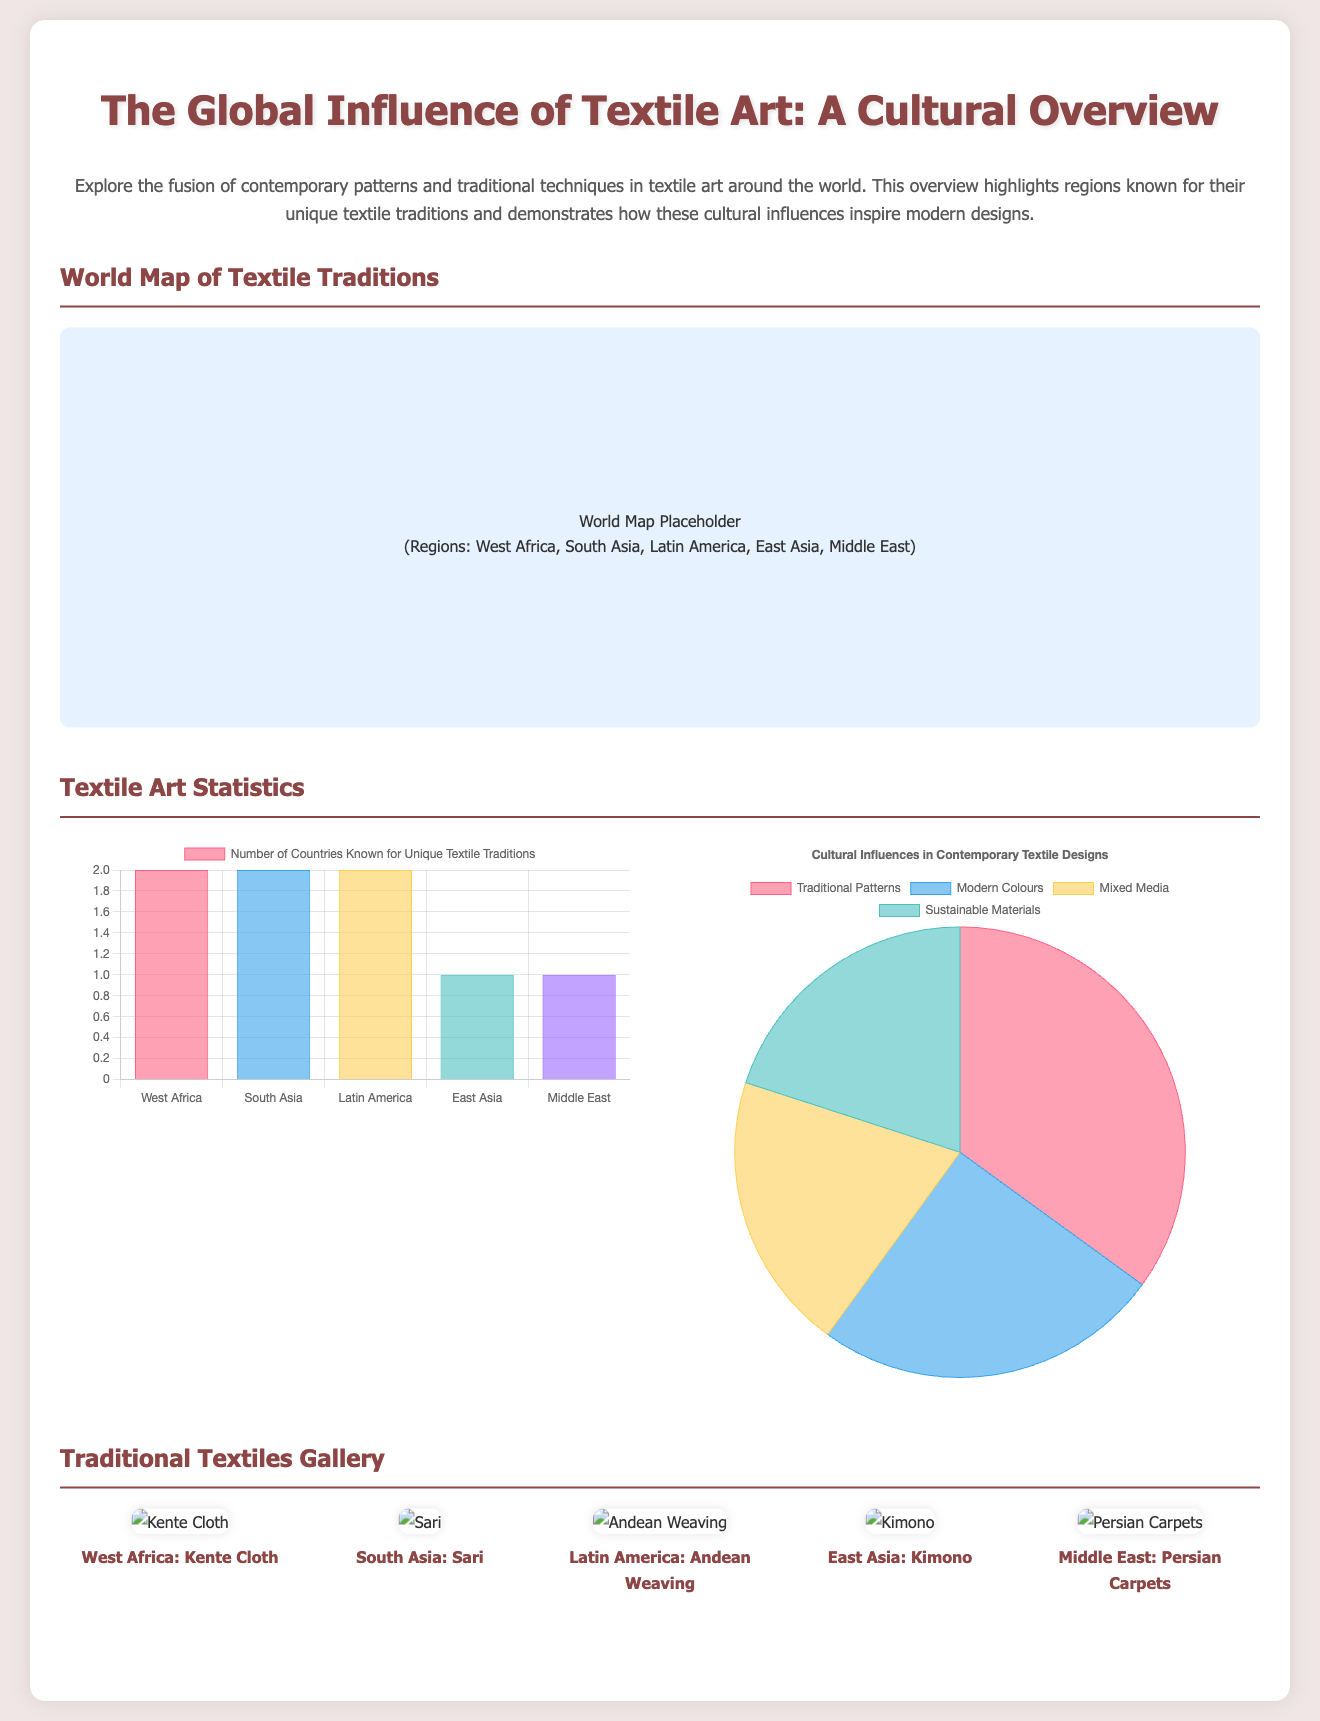what is the title of the infographic? The title is prominently displayed at the top of the document, summarizing the subject matter.
Answer: The Global Influence of Textile Art: A Cultural Overview how many regions are highlighted for their unique textile traditions? The document lists five distinct regions known for their textile traditions in the bar chart and the world map.
Answer: 5 what traditional textile is associated with South Asia? The traditional textile for this region is identified in the images section of the document.
Answer: Sari what is the percentage of cultural influences displayed as 'Traditional Patterns' in contemporary textile designs? The pie chart provides the data showing how traditional patterns influence contemporary designs.
Answer: 35 which region is associated with Kente Cloth? This information is found in the gallery of traditional textiles accompanying relevant images.
Answer: West Africa what color represents 'Mixed Media' in the pie chart? Each segment of the pie chart is linked to a distinct color corresponding to cultural influences.
Answer: Light Yellow what is the purpose of the world map included in the document? The map visually represents different regions and their textile traditions.
Answer: To showcase textile traditions how many countries are known for unique textile traditions in East Asia? The bar chart explicitly provides the number of countries for each highlighted region.
Answer: 1 what traditional textile is featured from the Middle East? This is indicated through an image caption in the traditional textiles gallery.
Answer: Persian Carpets 